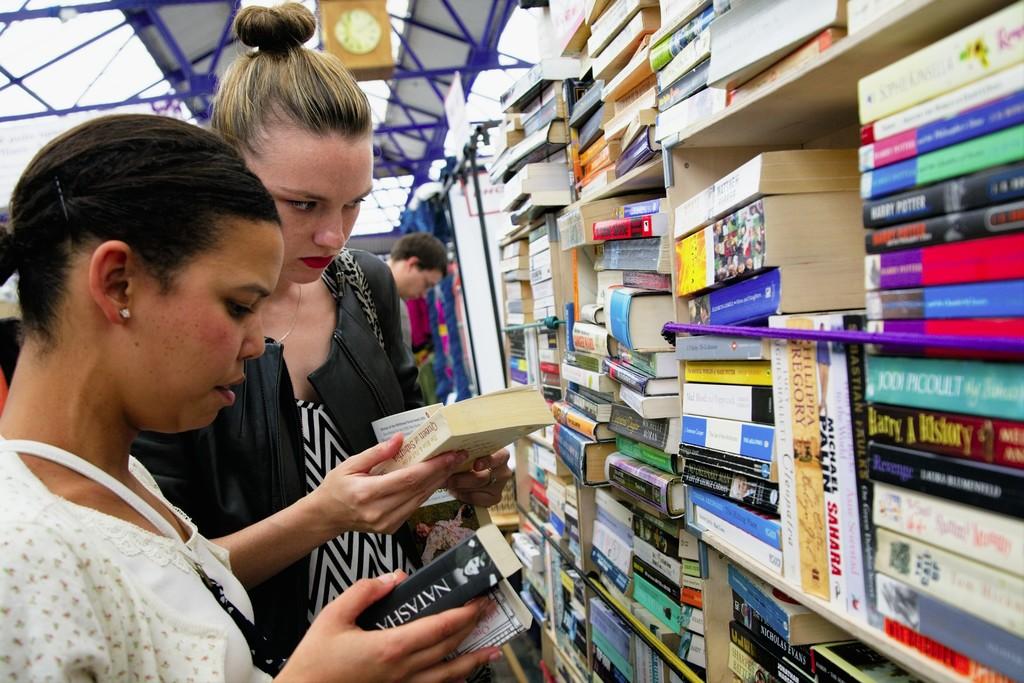Name a title of a book?
Offer a terse response. Harry a history. 